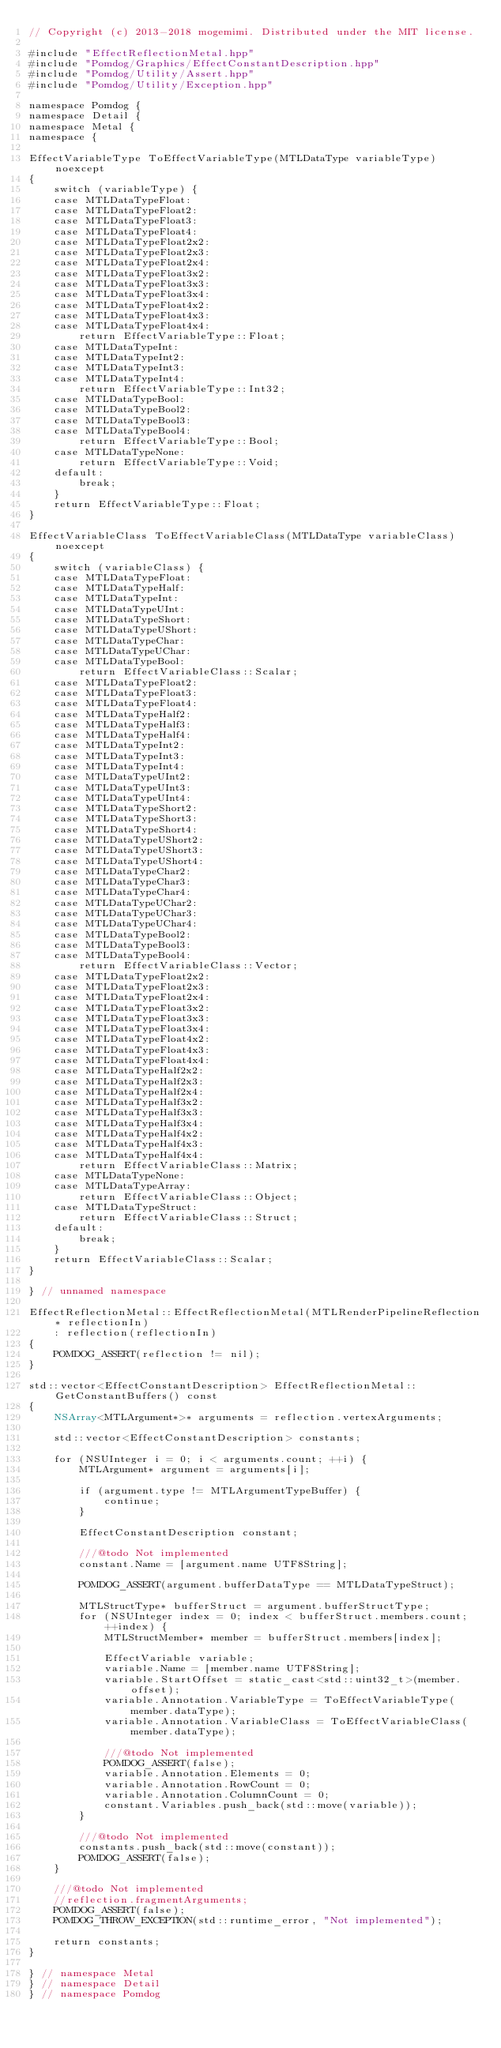<code> <loc_0><loc_0><loc_500><loc_500><_ObjectiveC_>// Copyright (c) 2013-2018 mogemimi. Distributed under the MIT license.

#include "EffectReflectionMetal.hpp"
#include "Pomdog/Graphics/EffectConstantDescription.hpp"
#include "Pomdog/Utility/Assert.hpp"
#include "Pomdog/Utility/Exception.hpp"

namespace Pomdog {
namespace Detail {
namespace Metal {
namespace {

EffectVariableType ToEffectVariableType(MTLDataType variableType) noexcept
{
    switch (variableType) {
    case MTLDataTypeFloat:
    case MTLDataTypeFloat2:
    case MTLDataTypeFloat3:
    case MTLDataTypeFloat4:
    case MTLDataTypeFloat2x2:
    case MTLDataTypeFloat2x3:
    case MTLDataTypeFloat2x4:
    case MTLDataTypeFloat3x2:
    case MTLDataTypeFloat3x3:
    case MTLDataTypeFloat3x4:
    case MTLDataTypeFloat4x2:
    case MTLDataTypeFloat4x3:
    case MTLDataTypeFloat4x4:
        return EffectVariableType::Float;
    case MTLDataTypeInt:
    case MTLDataTypeInt2:
    case MTLDataTypeInt3:
    case MTLDataTypeInt4:
        return EffectVariableType::Int32;
    case MTLDataTypeBool:
    case MTLDataTypeBool2:
    case MTLDataTypeBool3:
    case MTLDataTypeBool4:
        return EffectVariableType::Bool;
    case MTLDataTypeNone:
        return EffectVariableType::Void;
    default:
        break;
    }
    return EffectVariableType::Float;
}

EffectVariableClass ToEffectVariableClass(MTLDataType variableClass) noexcept
{
    switch (variableClass) {
    case MTLDataTypeFloat:
    case MTLDataTypeHalf:
    case MTLDataTypeInt:
    case MTLDataTypeUInt:
    case MTLDataTypeShort:
    case MTLDataTypeUShort:
    case MTLDataTypeChar:
    case MTLDataTypeUChar:
    case MTLDataTypeBool:
        return EffectVariableClass::Scalar;
    case MTLDataTypeFloat2:
    case MTLDataTypeFloat3:
    case MTLDataTypeFloat4:
    case MTLDataTypeHalf2:
    case MTLDataTypeHalf3:
    case MTLDataTypeHalf4:
    case MTLDataTypeInt2:
    case MTLDataTypeInt3:
    case MTLDataTypeInt4:
    case MTLDataTypeUInt2:
    case MTLDataTypeUInt3:
    case MTLDataTypeUInt4:
    case MTLDataTypeShort2:
    case MTLDataTypeShort3:
    case MTLDataTypeShort4:
    case MTLDataTypeUShort2:
    case MTLDataTypeUShort3:
    case MTLDataTypeUShort4:
    case MTLDataTypeChar2:
    case MTLDataTypeChar3:
    case MTLDataTypeChar4:
    case MTLDataTypeUChar2:
    case MTLDataTypeUChar3:
    case MTLDataTypeUChar4:
    case MTLDataTypeBool2:
    case MTLDataTypeBool3:
    case MTLDataTypeBool4:
        return EffectVariableClass::Vector;
    case MTLDataTypeFloat2x2:
    case MTLDataTypeFloat2x3:
    case MTLDataTypeFloat2x4:
    case MTLDataTypeFloat3x2:
    case MTLDataTypeFloat3x3:
    case MTLDataTypeFloat3x4:
    case MTLDataTypeFloat4x2:
    case MTLDataTypeFloat4x3:
    case MTLDataTypeFloat4x4:
    case MTLDataTypeHalf2x2:
    case MTLDataTypeHalf2x3:
    case MTLDataTypeHalf2x4:
    case MTLDataTypeHalf3x2:
    case MTLDataTypeHalf3x3:
    case MTLDataTypeHalf3x4:
    case MTLDataTypeHalf4x2:
    case MTLDataTypeHalf4x3:
    case MTLDataTypeHalf4x4:
        return EffectVariableClass::Matrix;
    case MTLDataTypeNone:
    case MTLDataTypeArray:
        return EffectVariableClass::Object;
    case MTLDataTypeStruct:
        return EffectVariableClass::Struct;
    default:
        break;
    }
    return EffectVariableClass::Scalar;
}

} // unnamed namespace

EffectReflectionMetal::EffectReflectionMetal(MTLRenderPipelineReflection* reflectionIn)
    : reflection(reflectionIn)
{
    POMDOG_ASSERT(reflection != nil);
}

std::vector<EffectConstantDescription> EffectReflectionMetal::GetConstantBuffers() const
{
    NSArray<MTLArgument*>* arguments = reflection.vertexArguments;

    std::vector<EffectConstantDescription> constants;

    for (NSUInteger i = 0; i < arguments.count; ++i) {
        MTLArgument* argument = arguments[i];

        if (argument.type != MTLArgumentTypeBuffer) {
            continue;
        }

        EffectConstantDescription constant;

        ///@todo Not implemented
        constant.Name = [argument.name UTF8String];

        POMDOG_ASSERT(argument.bufferDataType == MTLDataTypeStruct);

        MTLStructType* bufferStruct = argument.bufferStructType;
        for (NSUInteger index = 0; index < bufferStruct.members.count; ++index) {
            MTLStructMember* member = bufferStruct.members[index];

            EffectVariable variable;
            variable.Name = [member.name UTF8String];
            variable.StartOffset = static_cast<std::uint32_t>(member.offset);
            variable.Annotation.VariableType = ToEffectVariableType(member.dataType);
            variable.Annotation.VariableClass = ToEffectVariableClass(member.dataType);

            ///@todo Not implemented
            POMDOG_ASSERT(false);
            variable.Annotation.Elements = 0;
            variable.Annotation.RowCount = 0;
            variable.Annotation.ColumnCount = 0;
            constant.Variables.push_back(std::move(variable));
        }

        ///@todo Not implemented
        constants.push_back(std::move(constant));
        POMDOG_ASSERT(false);
    }

    ///@todo Not implemented
    //reflection.fragmentArguments;
    POMDOG_ASSERT(false);
    POMDOG_THROW_EXCEPTION(std::runtime_error, "Not implemented");

    return constants;
}

} // namespace Metal
} // namespace Detail
} // namespace Pomdog
</code> 